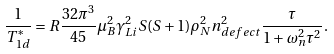<formula> <loc_0><loc_0><loc_500><loc_500>\frac { 1 } { T _ { 1 d } ^ { * } } = R \frac { 3 2 \pi ^ { 3 } } { 4 5 } \mu _ { B } ^ { 2 } \gamma _ { L i } ^ { 2 } S ( S + 1 ) \rho _ { N } ^ { 2 } n _ { d e f e c t } ^ { 2 } \frac { \tau } { 1 + \omega _ { n } ^ { 2 } \tau ^ { 2 } } .</formula> 